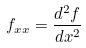Convert formula to latex. <formula><loc_0><loc_0><loc_500><loc_500>f _ { x x } = \frac { d ^ { 2 } f } { d x ^ { 2 } }</formula> 